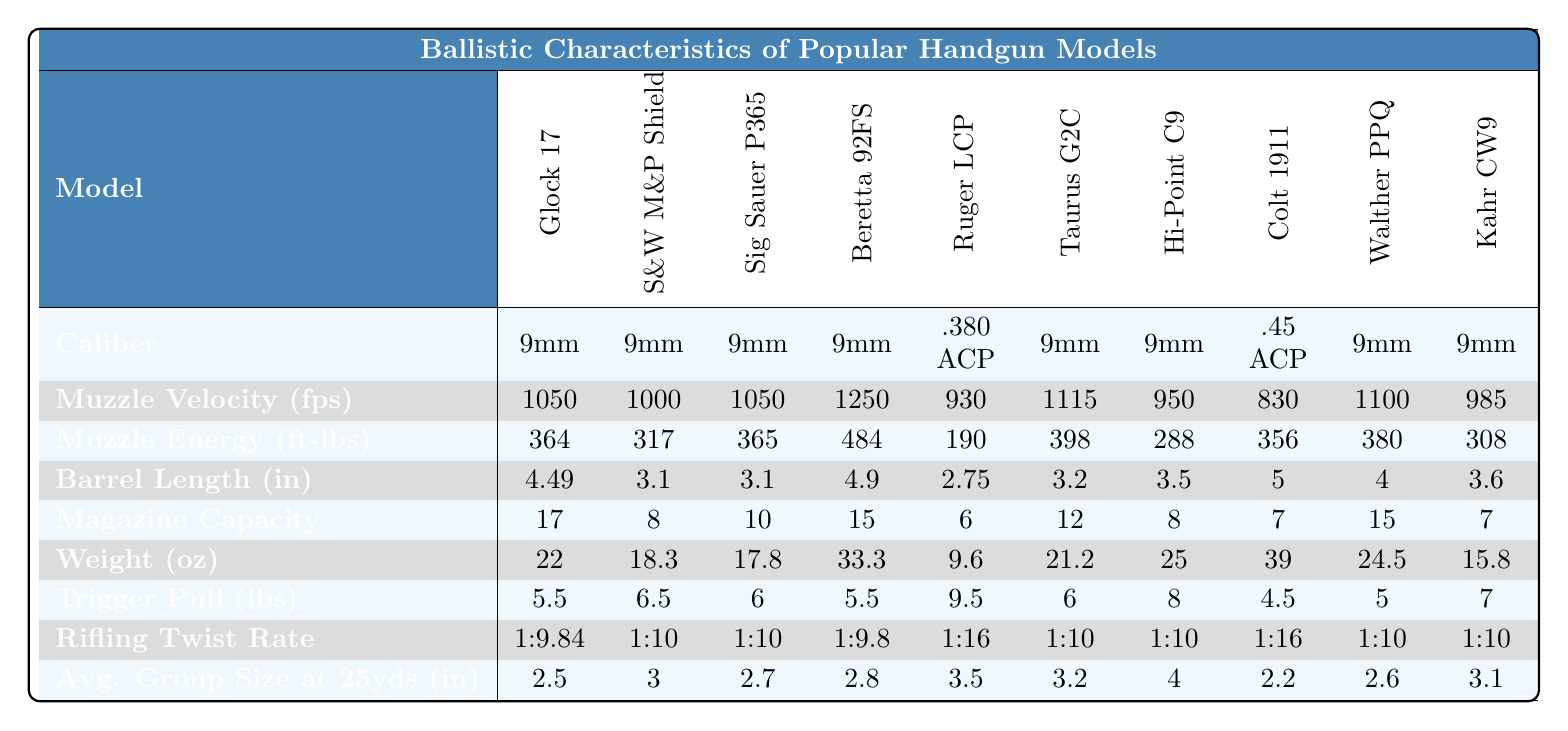What caliber is the Glock 17? The table lists the caliber for each handgun model, and for the Glock 17, the caliber is specified as 9mm.
Answer: 9mm What is the weight of the Smith & Wesson M&P Shield? The weight is provided in ounces for each handgun model, and the weight of the Smith & Wesson M&P Shield is 18.3 oz.
Answer: 18.3 oz Which handgun model has the highest muzzle energy? By comparing the muzzle energy values listed, the Beretta 92FS has the highest muzzle energy at 484 ft-lbs.
Answer: Beretta 92FS What is the average magazine capacity of these handgun models? To find the average magazine capacity, sum the magazine capacities: (17 + 8 + 10 + 15 + 6 + 12 + 8 + 7 + 15 + 7) = 99, then divide by the number of models (10), resulting in 99/10 = 9.9.
Answer: 9.9 Is the trigger pull weight of the Colt 1911 greater than the average trigger pull weight of the handguns listed? The trigger pull weights are: 5.5, 6.5, 6, 5.5, 9.5, 6, 8, 4.5, 5, 7. Their average is 6.1. The Colt 1911 has a trigger pull weight of 4.5, which is less than the average.
Answer: No Which handgun has the shortest barrel length? The barrel lengths are listed, and the Ruger LCP has the shortest barrel length at 2.75 inches.
Answer: Ruger LCP How many handguns have a caliber of .380 ACP? Review the caliber column to count the occurrences of .380 ACP, which appears once (Ruger LCP), indicating there is 1 handgun in this category.
Answer: 1 If you combine the muzzle velocities of the Ruger LCP and the Colt 1911, what is the result? The muzzle velocities for Ruger LCP and Colt 1911 are 930 fps and 830 fps, respectively. Summing these gives 930 + 830 = 1760 fps.
Answer: 1760 fps Which handgun has the least average group size at 25 yards? The average group sizes are compared, and the Colt 1911 has the least average group size at 2.2 inches.
Answer: Colt 1911 Is there a significant difference in barrel length between the Glock 17 and the Taurus G2C? The barrel lengths for Glock 17 and Taurus G2C are 4.49 inches and 3.2 inches, respectively. The difference is 4.49 - 3.2 = 1.29 inches, which is a significant difference.
Answer: Yes What handgun models have a trigger pull weight below 6 pounds? The models with a trigger pull weight below 6 pounds are Glock 17 (5.5), Beretta 92FS (5.5), Colt 1911 (4.5), and Walther PPQ (5), totaling 4 models.
Answer: 4 models 